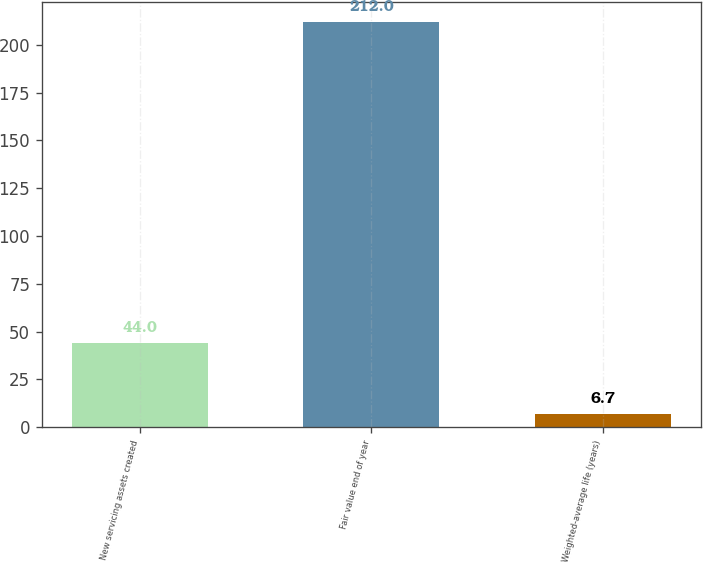Convert chart. <chart><loc_0><loc_0><loc_500><loc_500><bar_chart><fcel>New servicing assets created<fcel>Fair value end of year<fcel>Weighted-average life (years)<nl><fcel>44<fcel>212<fcel>6.7<nl></chart> 